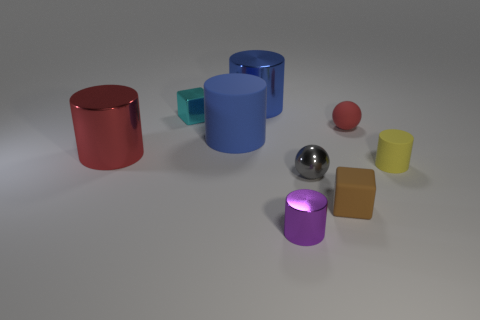Subtract all yellow cylinders. How many cylinders are left? 4 Subtract all tiny matte cylinders. How many cylinders are left? 4 Subtract all red cylinders. Subtract all yellow spheres. How many cylinders are left? 4 Add 1 small metallic spheres. How many objects exist? 10 Subtract all balls. How many objects are left? 7 Add 9 blue rubber cylinders. How many blue rubber cylinders are left? 10 Add 1 red metal objects. How many red metal objects exist? 2 Subtract 0 purple cubes. How many objects are left? 9 Subtract all large metallic blocks. Subtract all large blue matte things. How many objects are left? 8 